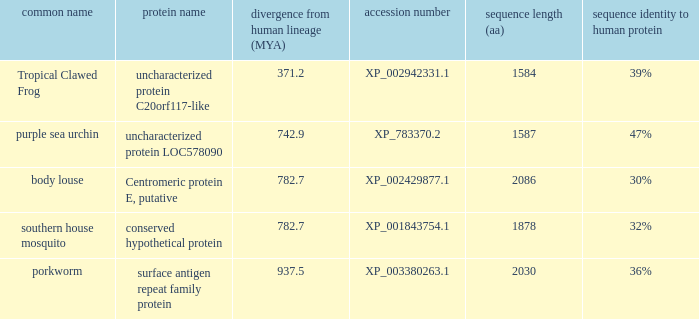What is the accession number of the protein with the common name Purple Sea Urchin? XP_783370.2. 